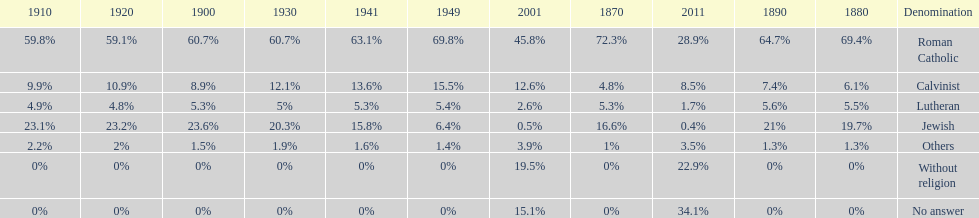Could you help me parse every detail presented in this table? {'header': ['1910', '1920', '1900', '1930', '1941', '1949', '2001', '1870', '2011', '1890', '1880', 'Denomination'], 'rows': [['59.8%', '59.1%', '60.7%', '60.7%', '63.1%', '69.8%', '45.8%', '72.3%', '28.9%', '64.7%', '69.4%', 'Roman Catholic'], ['9.9%', '10.9%', '8.9%', '12.1%', '13.6%', '15.5%', '12.6%', '4.8%', '8.5%', '7.4%', '6.1%', 'Calvinist'], ['4.9%', '4.8%', '5.3%', '5%', '5.3%', '5.4%', '2.6%', '5.3%', '1.7%', '5.6%', '5.5%', 'Lutheran'], ['23.1%', '23.2%', '23.6%', '20.3%', '15.8%', '6.4%', '0.5%', '16.6%', '0.4%', '21%', '19.7%', 'Jewish'], ['2.2%', '2%', '1.5%', '1.9%', '1.6%', '1.4%', '3.9%', '1%', '3.5%', '1.3%', '1.3%', 'Others'], ['0%', '0%', '0%', '0%', '0%', '0%', '19.5%', '0%', '22.9%', '0%', '0%', 'Without religion'], ['0%', '0%', '0%', '0%', '0%', '0%', '15.1%', '0%', '34.1%', '0%', '0%', 'No answer']]} Which religious denomination had a higher percentage in 1900, jewish or roman catholic? Roman Catholic. 